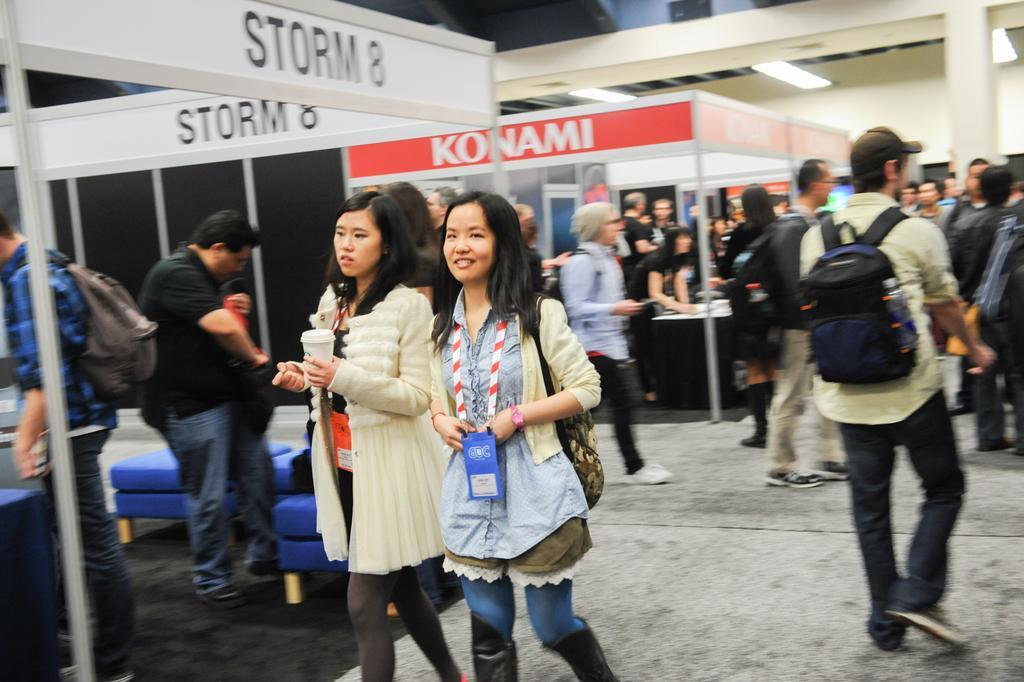Can you describe this image briefly? In this image I can see the group of people with different color dresses. I can see few people are wearing the bags and one person is holding the cup. In the background I can see the boards and lights in the top. 